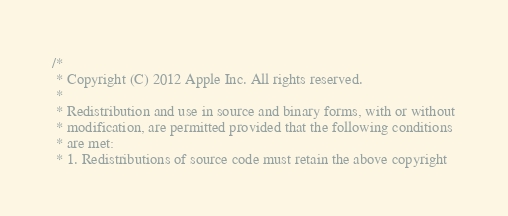Convert code to text. <code><loc_0><loc_0><loc_500><loc_500><_ObjectiveC_>/*
 * Copyright (C) 2012 Apple Inc. All rights reserved.
 *
 * Redistribution and use in source and binary forms, with or without
 * modification, are permitted provided that the following conditions
 * are met:
 * 1. Redistributions of source code must retain the above copyright</code> 